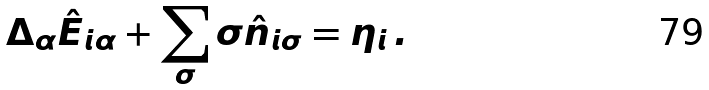Convert formula to latex. <formula><loc_0><loc_0><loc_500><loc_500>\Delta _ { \alpha } \hat { E } _ { i \alpha } + \sum _ { \sigma } \sigma \hat { n } _ { i \sigma } = \eta _ { i } \, .</formula> 